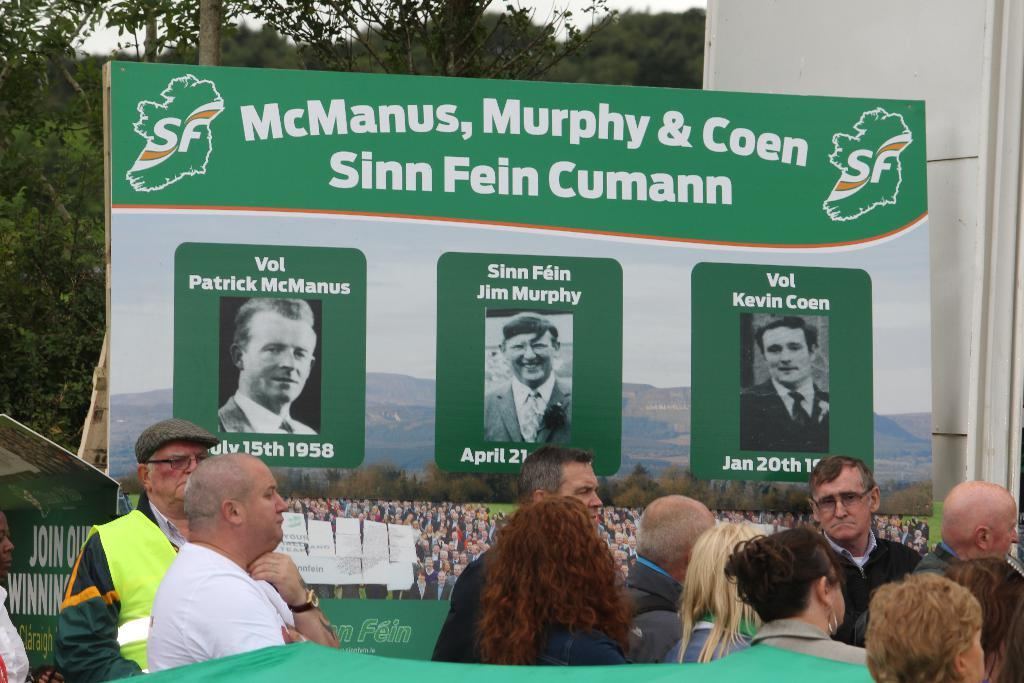Who or what is present in the image? There are people in the image. What object is visible in the image that contains pictures? There is a board in the image that contains pictures of people, a mountain, and the sky. What is written on the board? There is writing on the board. What can be seen in the background of the image? There are trees in the background of the image. How does the board feel about the waste produced in the image? The board does not have feelings, as it is an inanimate object. Additionally, there is no mention of waste in the image. 